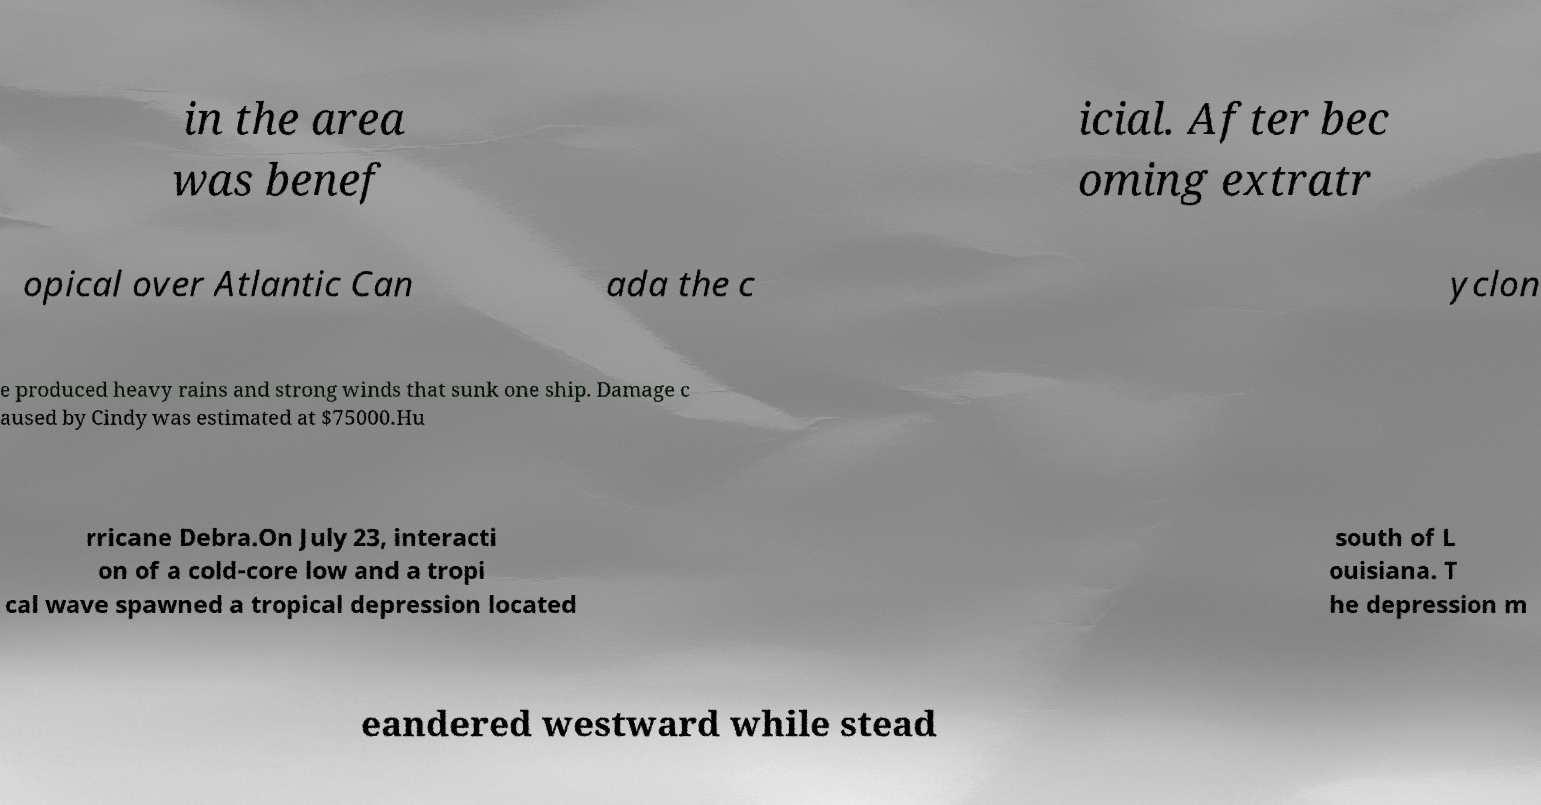Can you read and provide the text displayed in the image?This photo seems to have some interesting text. Can you extract and type it out for me? in the area was benef icial. After bec oming extratr opical over Atlantic Can ada the c yclon e produced heavy rains and strong winds that sunk one ship. Damage c aused by Cindy was estimated at $75000.Hu rricane Debra.On July 23, interacti on of a cold-core low and a tropi cal wave spawned a tropical depression located south of L ouisiana. T he depression m eandered westward while stead 